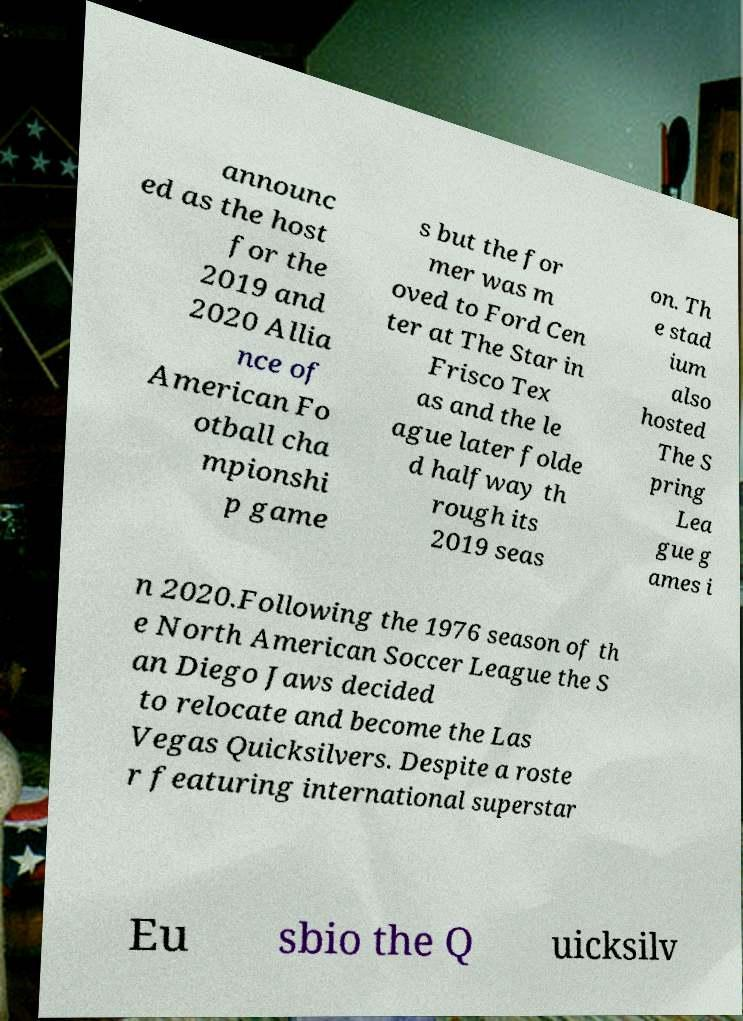Please identify and transcribe the text found in this image. announc ed as the host for the 2019 and 2020 Allia nce of American Fo otball cha mpionshi p game s but the for mer was m oved to Ford Cen ter at The Star in Frisco Tex as and the le ague later folde d halfway th rough its 2019 seas on. Th e stad ium also hosted The S pring Lea gue g ames i n 2020.Following the 1976 season of th e North American Soccer League the S an Diego Jaws decided to relocate and become the Las Vegas Quicksilvers. Despite a roste r featuring international superstar Eu sbio the Q uicksilv 